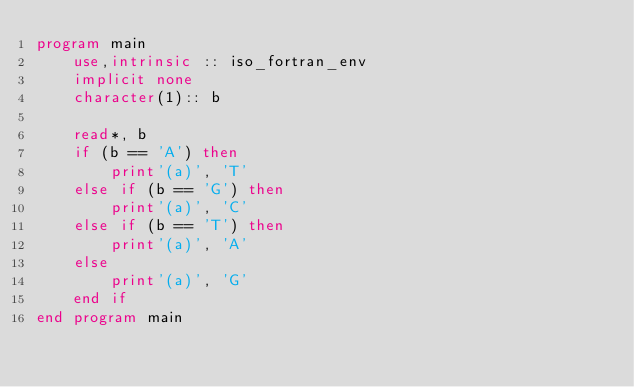<code> <loc_0><loc_0><loc_500><loc_500><_FORTRAN_>program main
    use,intrinsic :: iso_fortran_env
    implicit none
    character(1):: b

    read*, b
    if (b == 'A') then
        print'(a)', 'T'
    else if (b == 'G') then
        print'(a)', 'C'
    else if (b == 'T') then
        print'(a)', 'A'
    else
        print'(a)', 'G'
    end if
end program main</code> 